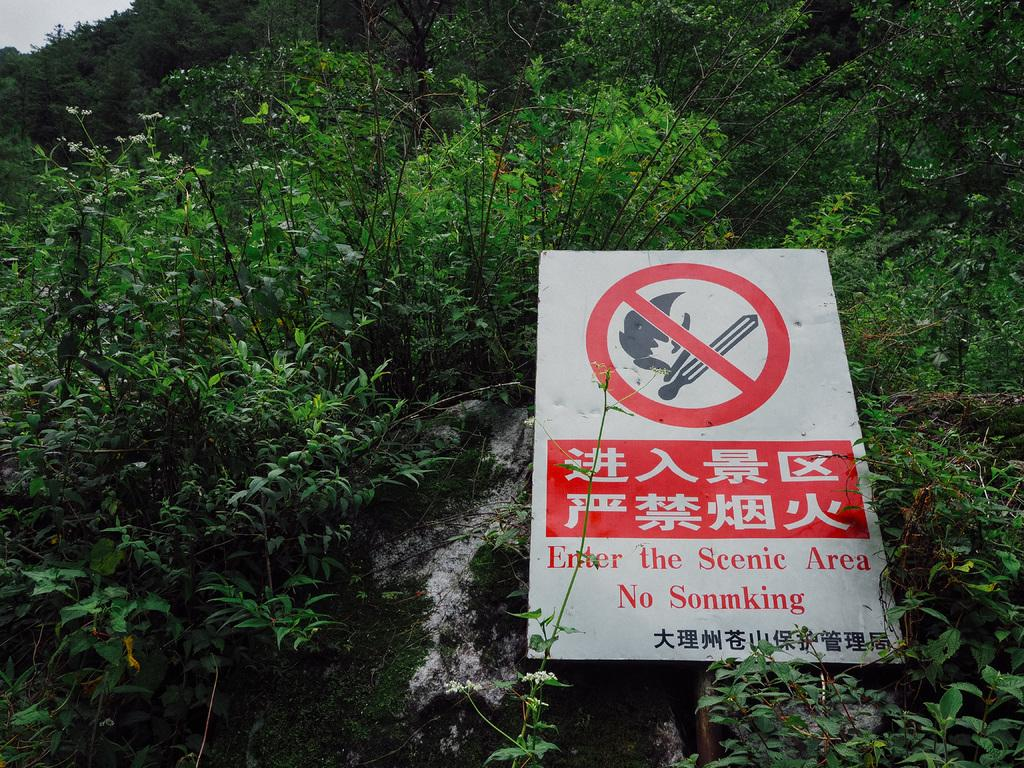What is the main object in the image? There is a sign board in the image. What else can be seen in the image besides the sign board? There are many plants in the image. What type of force is being applied to the boy in the image? There is no boy present in the image, so the question about force cannot be answered. 